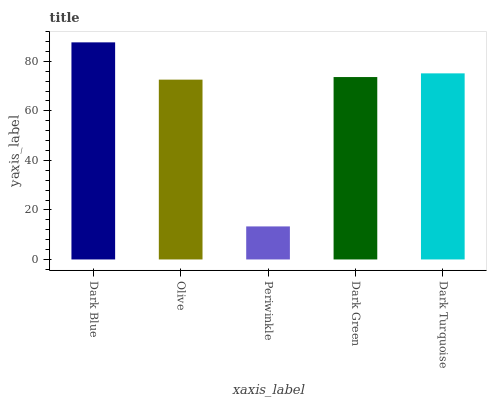Is Periwinkle the minimum?
Answer yes or no. Yes. Is Dark Blue the maximum?
Answer yes or no. Yes. Is Olive the minimum?
Answer yes or no. No. Is Olive the maximum?
Answer yes or no. No. Is Dark Blue greater than Olive?
Answer yes or no. Yes. Is Olive less than Dark Blue?
Answer yes or no. Yes. Is Olive greater than Dark Blue?
Answer yes or no. No. Is Dark Blue less than Olive?
Answer yes or no. No. Is Dark Green the high median?
Answer yes or no. Yes. Is Dark Green the low median?
Answer yes or no. Yes. Is Dark Turquoise the high median?
Answer yes or no. No. Is Olive the low median?
Answer yes or no. No. 